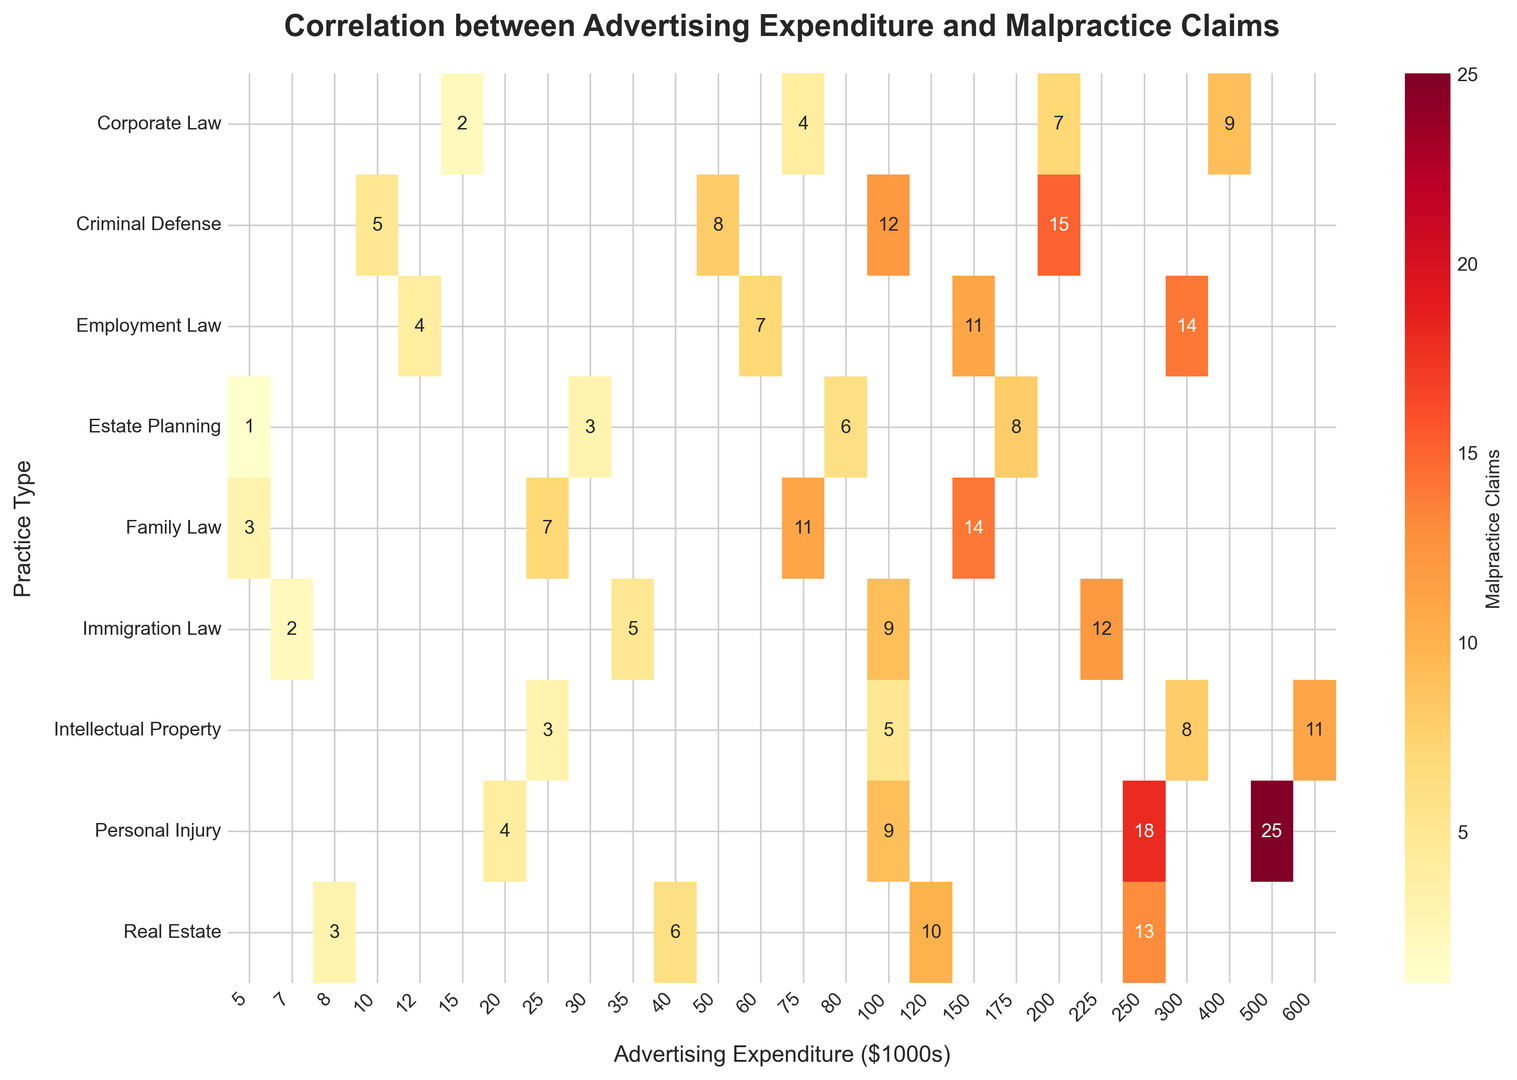Which practice type has the highest number of malpractice claims for any given level of advertising expenditure? To find the answer, inspect the heatmap and identify the cell with the highest value. The highest value is 25, found in the Personal Injury row at the $500k advertising expenditure column.
Answer: Personal Injury Which practice type appears to have the lowest number of malpractice claims when advertising expenditure is $50k? Look at the column for $50k advertising expenditure. The number of malpractice claims is displayed in the cells of this column for each practice type. Family Law has the lowest number of claims, which is 3.
Answer: Family Law How does the number of malpractice claims change for Real Estate practice as advertising expenditure increases from $8k to $250k? Examine the row for Real Estate practice. Track the change in the values from the $8k column (3 claims) to the $250k column (13 claims). The claims increase from 3 to 13 as the expenditure increases.
Answer: Increases from 3 to 13 What is the total number of malpractice claims for Corporate Law practice at advertising expenditures of $15k, $75k, and $200k? Sum the corresponding values in the row for Corporate Law: 2 (at $15k) + 4 (at $75k) + 7 (at $200k). Total is 2 + 4 + 7 = 13.
Answer: 13 How does the average number of malpractice claims compare between Employment Law and Immigration Law practices at various levels of advertising expenditure? Calculate the average for Employment Law (4, 7, 11, 14) and Immigration Law (2, 5, 9, 12). For Employment Law: (4 + 7 + 11 + 14) / 4 = 36 / 4 = 9. For Immigration Law: (2 + 5 + 9 + 12) / 4 = 28 / 4 = 7. Employment Law has a higher average number of malpractice claims.
Answer: Employment Law higher at 9, Immigration Law at 7 Which practice type shows the least variance in malpractice claims across all levels of advertising expenditure? Look at the spread of the numbers in each row. Estate Planning has the least variance, varying from 1 to 8.
Answer: Estate Planning Among the practice types, which shows the steepest increase in malpractice claims when advertising expenditure increases from the lowest to the highest value in the dataset? Identify the practice type with the highest increase in claims from its lowest value to its highest value. Personal Injury shows an increase from 4 to 25, a difference of 21 claims.
Answer: Personal Injury What is the difference in the number of malpractice claims between Family Law and Real Estate at the $150k advertising expenditure level? Check the $150k column for both Family Law (14 claims) and Real Estate (not available, interpolate between $120k and $250k for approximate comparison). Family Law has a higher value. Difference cannot be exactly calculated due to missing data.
Answer: Family Law higher, exact difference indeterminable 